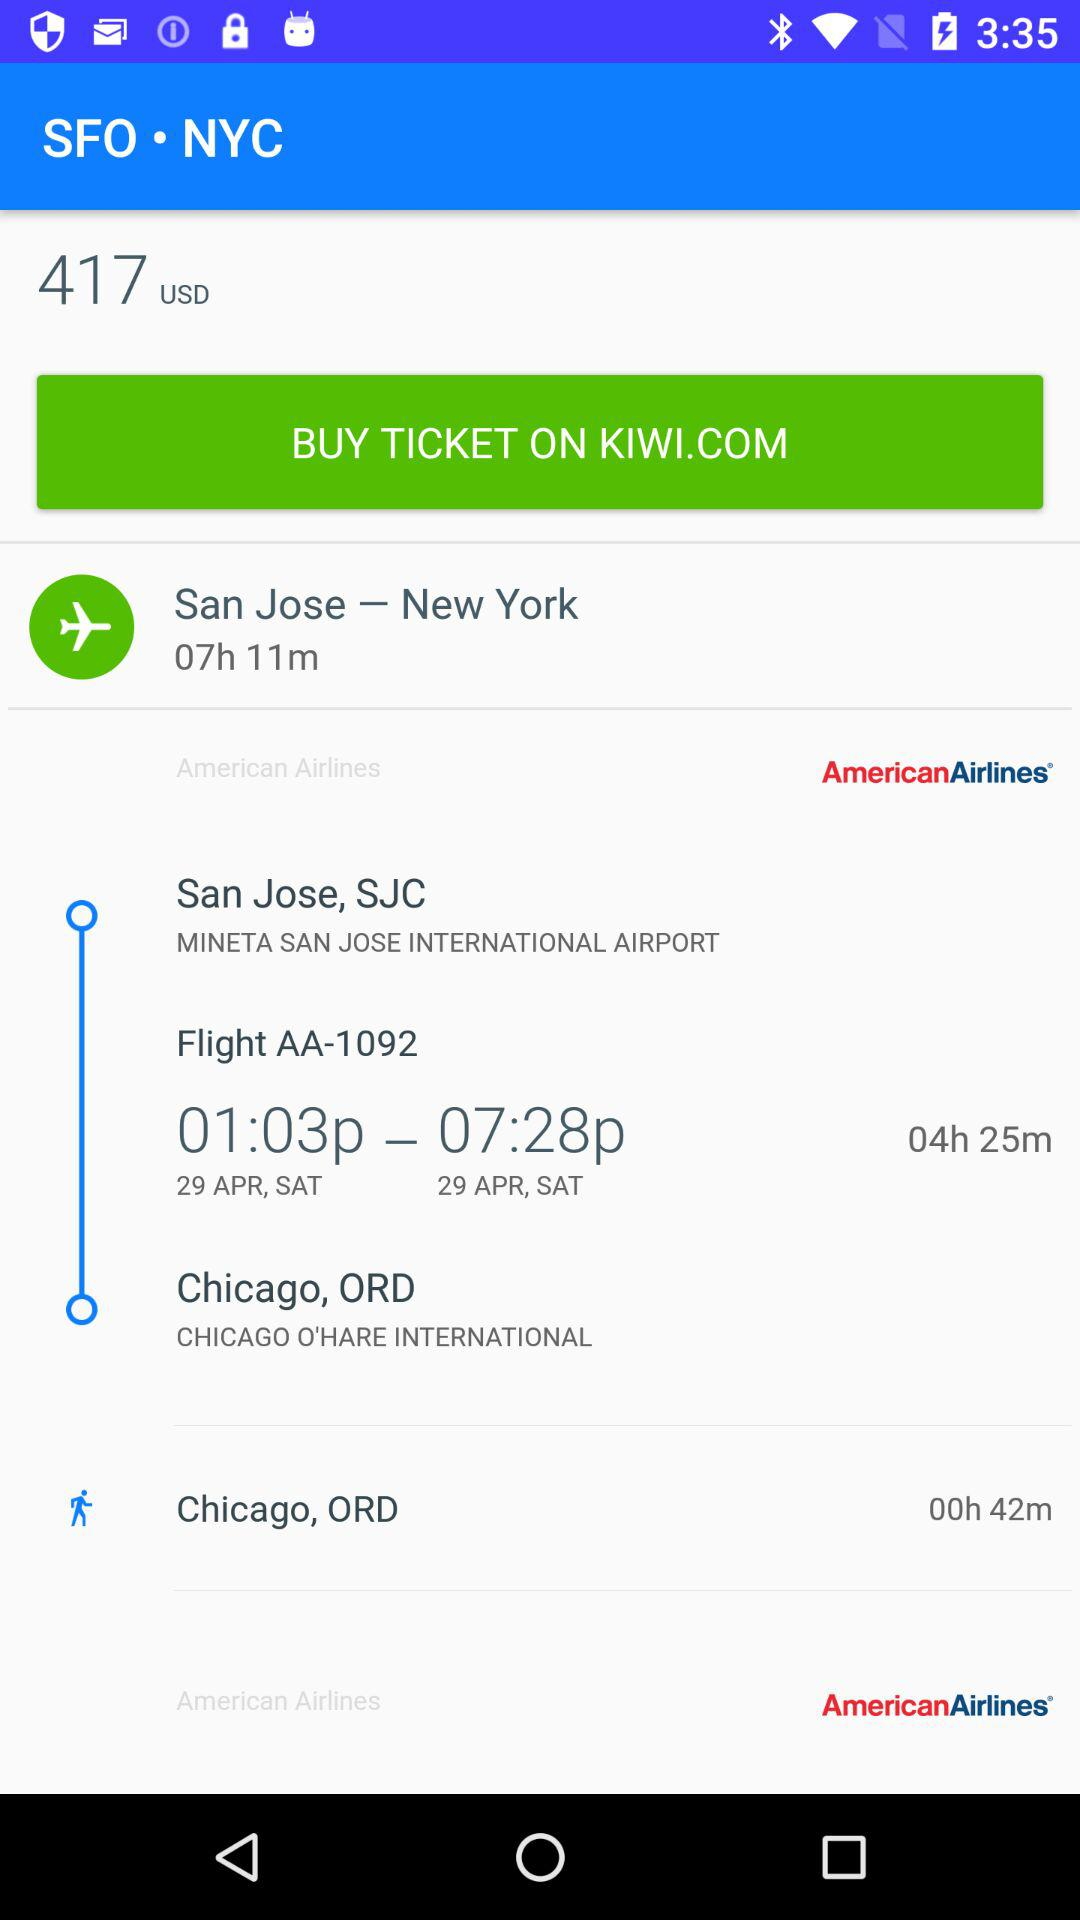What is the duration of travel from SJC to ORD? The duration is 4 hours and 25 minutes. 